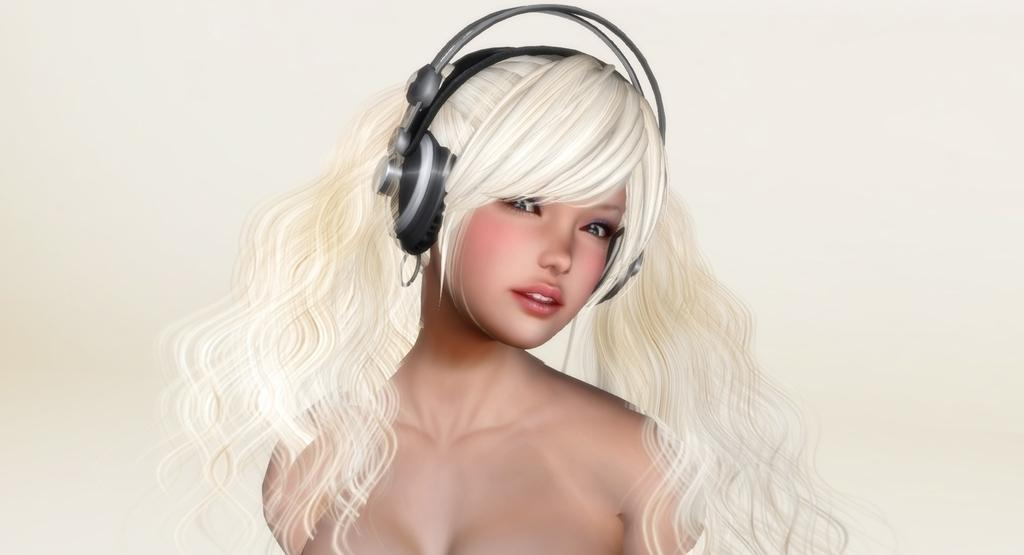What is the main subject of the picture? The main subject of the picture is an animated woman. What is the woman wearing in the picture? The woman is wearing a headset in the picture. What is the color of the background in the picture? The background in the picture is white. How many apples are on the table in the image? There are no apples present in the image; it features an animated woman wearing a headset against a white background. What type of agreement is being discussed in the image? There is no discussion or agreement present in the image; it only features an animated woman wearing a headset against a white background. 